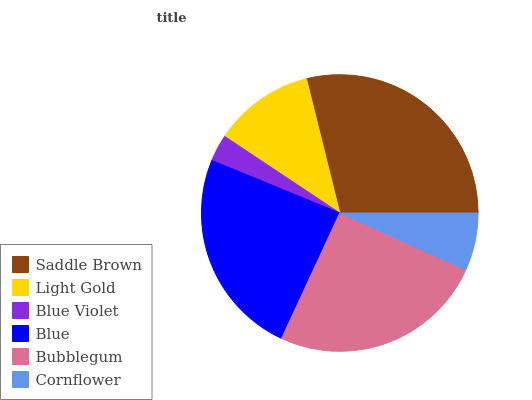Is Blue Violet the minimum?
Answer yes or no. Yes. Is Saddle Brown the maximum?
Answer yes or no. Yes. Is Light Gold the minimum?
Answer yes or no. No. Is Light Gold the maximum?
Answer yes or no. No. Is Saddle Brown greater than Light Gold?
Answer yes or no. Yes. Is Light Gold less than Saddle Brown?
Answer yes or no. Yes. Is Light Gold greater than Saddle Brown?
Answer yes or no. No. Is Saddle Brown less than Light Gold?
Answer yes or no. No. Is Blue the high median?
Answer yes or no. Yes. Is Light Gold the low median?
Answer yes or no. Yes. Is Bubblegum the high median?
Answer yes or no. No. Is Cornflower the low median?
Answer yes or no. No. 